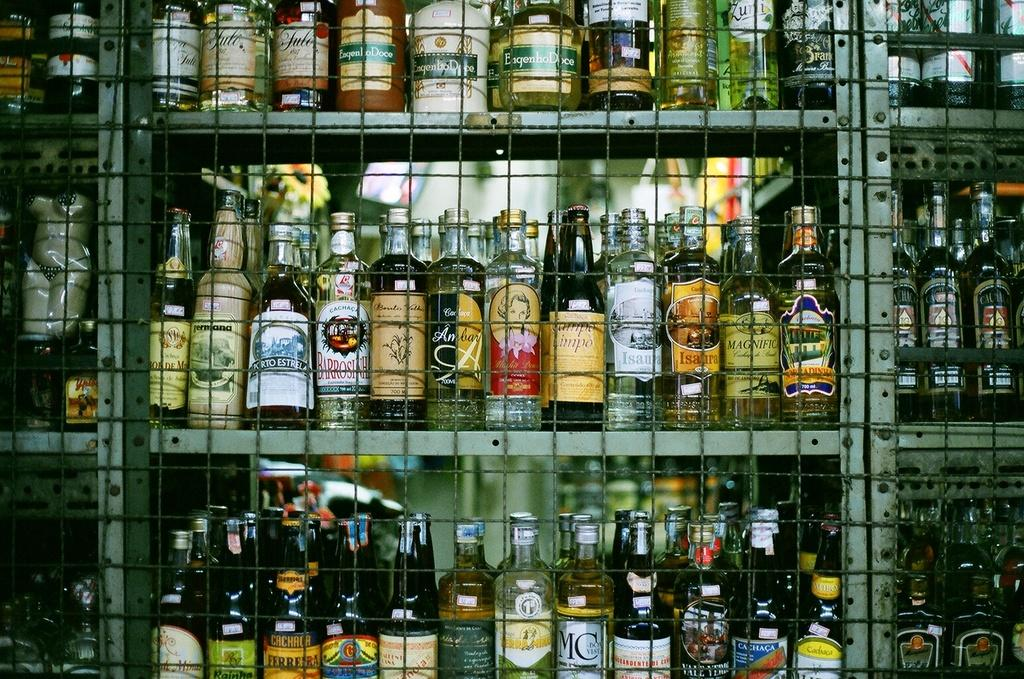<image>
Share a concise interpretation of the image provided. Store full of alcohol including Magnific behind a fence. 